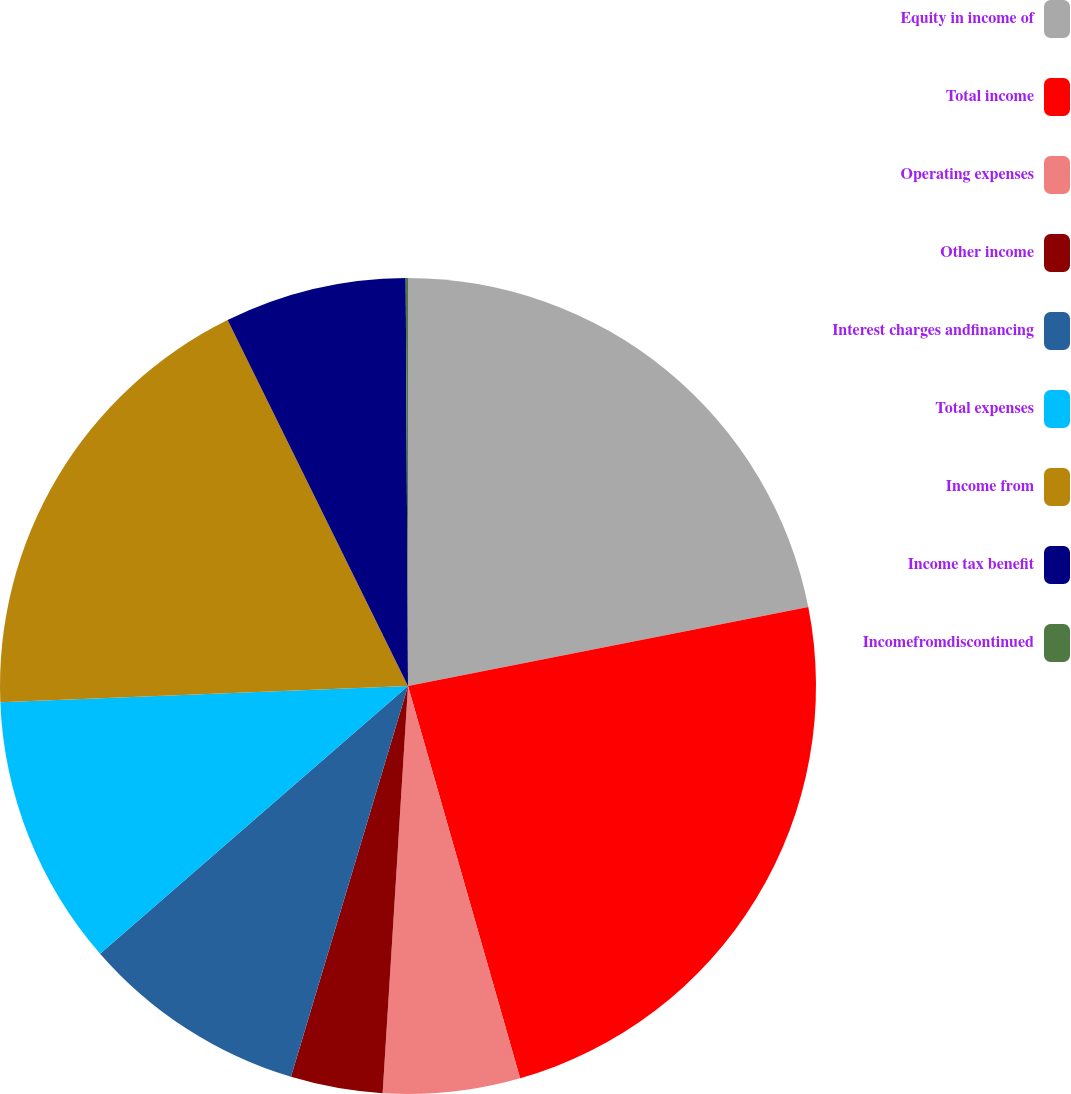<chart> <loc_0><loc_0><loc_500><loc_500><pie_chart><fcel>Equity in income of<fcel>Total income<fcel>Operating expenses<fcel>Other income<fcel>Interest charges andfinancing<fcel>Total expenses<fcel>Income from<fcel>Income tax benefit<fcel>Incomefromdiscontinued<nl><fcel>21.9%<fcel>23.67%<fcel>5.42%<fcel>3.64%<fcel>8.98%<fcel>10.76%<fcel>18.34%<fcel>7.2%<fcel>0.09%<nl></chart> 